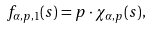<formula> <loc_0><loc_0><loc_500><loc_500>f _ { \alpha , p , 1 } ( s ) = p \cdot \chi _ { \alpha , p } ( s ) ,</formula> 